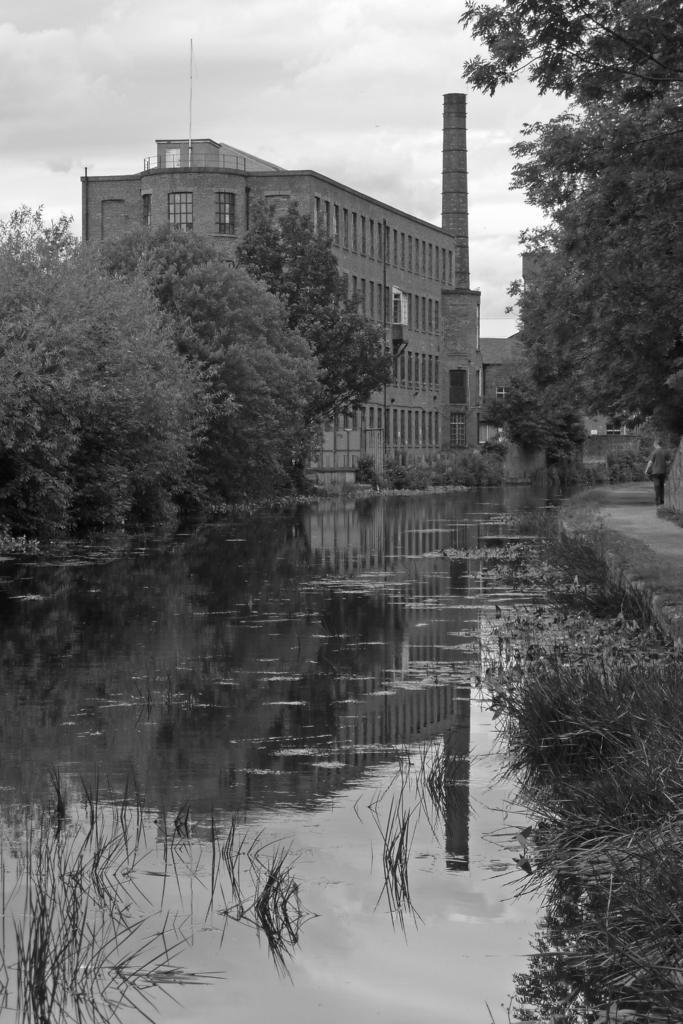Can you describe this image briefly? It looks like a black and white picture. We can see a man is standing on the path and on the left side of the man there is water, plants, trees, buildings and the sky. 